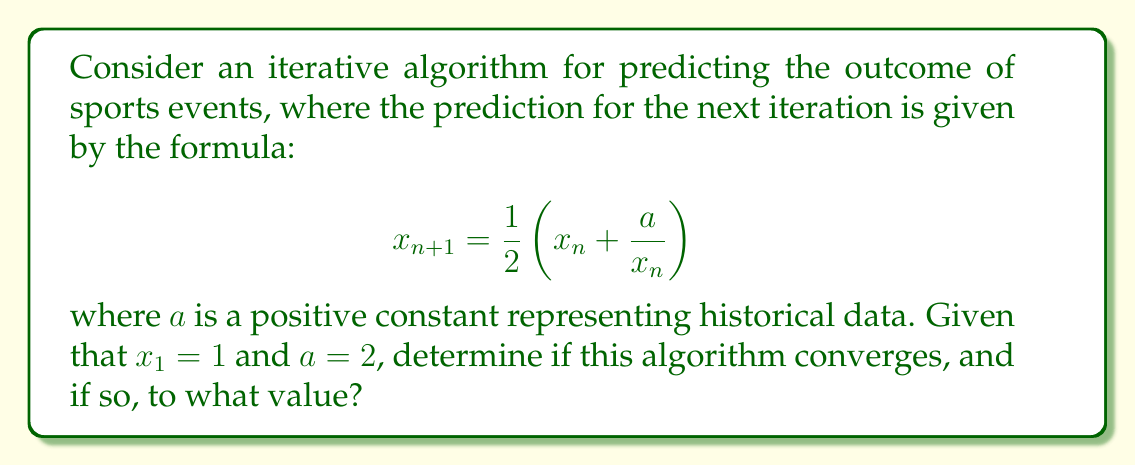What is the answer to this math problem? 1) First, let's analyze the behavior of this iterative algorithm:

   $$x_{n+1} = \frac{1}{2}(x_n + \frac{a}{x_n})$$

2) This is a well-known iteration called the Babylonian method or Heron's method for approximating square roots.

3) To determine convergence, we need to find the fixed point of this iteration. Let's call it $x^*$:

   $$x^* = \frac{1}{2}(x^* + \frac{a}{x^*})$$

4) Multiplying both sides by $2x^*$:

   $$2(x^*)^2 = (x^*)^2 + a$$

5) Simplifying:

   $$(x^*)^2 = a$$

6) Taking the square root of both sides:

   $$x^* = \sqrt{a}$$

7) In our case, $a = 2$, so the fixed point is $\sqrt{2}$.

8) To prove convergence, we can use the contraction mapping theorem. The derivative of our function is:

   $$f'(x) = \frac{1}{2}(1 - \frac{a}{x^2})$$

9) For $a = 2$, this derivative is always between -1 and 1 for $x > 0$, which guarantees convergence.

10) Therefore, the algorithm converges to $\sqrt{2}$ for any positive starting value.
Answer: Converges to $\sqrt{2}$ 